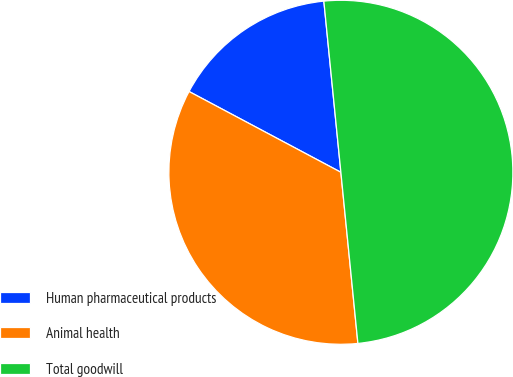Convert chart to OTSL. <chart><loc_0><loc_0><loc_500><loc_500><pie_chart><fcel>Human pharmaceutical products<fcel>Animal health<fcel>Total goodwill<nl><fcel>15.64%<fcel>34.36%<fcel>50.0%<nl></chart> 